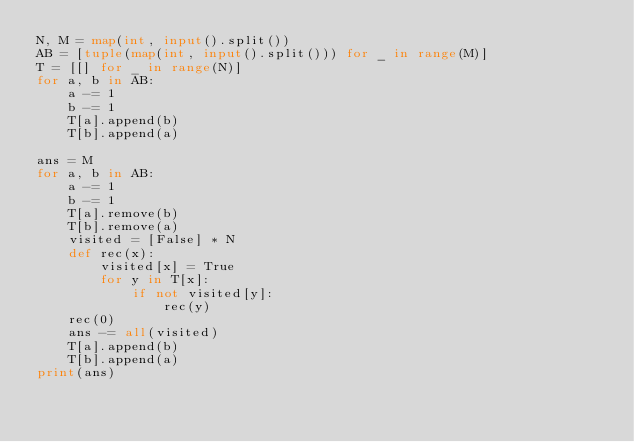<code> <loc_0><loc_0><loc_500><loc_500><_Python_>N, M = map(int, input().split())
AB = [tuple(map(int, input().split())) for _ in range(M)]
T = [[] for _ in range(N)]
for a, b in AB:
    a -= 1
    b -= 1
    T[a].append(b)
    T[b].append(a)

ans = M
for a, b in AB:
    a -= 1
    b -= 1
    T[a].remove(b)
    T[b].remove(a)
    visited = [False] * N
    def rec(x):
        visited[x] = True
        for y in T[x]:
            if not visited[y]:
                rec(y)
    rec(0)
    ans -= all(visited)
    T[a].append(b)
    T[b].append(a)
print(ans)</code> 